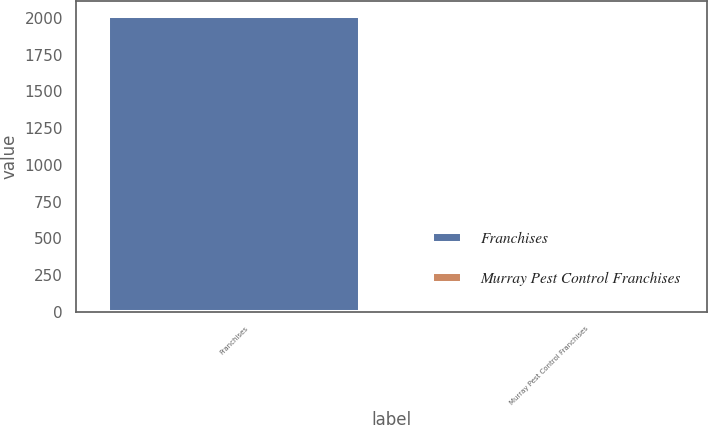Convert chart. <chart><loc_0><loc_0><loc_500><loc_500><bar_chart><fcel>Franchises<fcel>Murray Pest Control Franchises<nl><fcel>2016<fcel>4<nl></chart> 